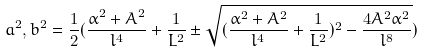Convert formula to latex. <formula><loc_0><loc_0><loc_500><loc_500>a ^ { 2 } , b ^ { 2 } = \frac { 1 } { 2 } ( \frac { \alpha ^ { 2 } + A ^ { 2 } } { l ^ { 4 } } + \frac { 1 } { L ^ { 2 } } \pm \sqrt { ( \frac { \alpha ^ { 2 } + A ^ { 2 } } { l ^ { 4 } } + \frac { 1 } { L ^ { 2 } } ) ^ { 2 } - \frac { 4 A ^ { 2 } \alpha ^ { 2 } } { l ^ { 8 } } } )</formula> 